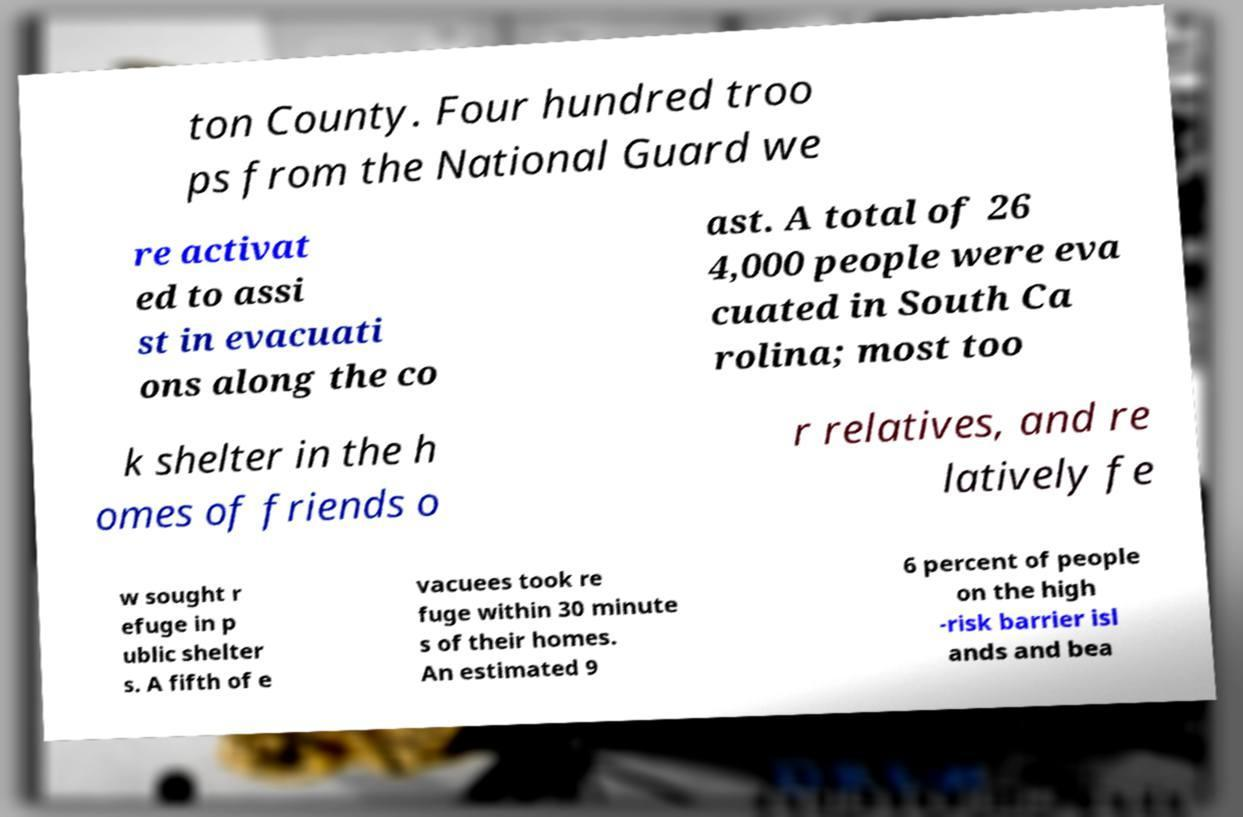Please identify and transcribe the text found in this image. ton County. Four hundred troo ps from the National Guard we re activat ed to assi st in evacuati ons along the co ast. A total of 26 4,000 people were eva cuated in South Ca rolina; most too k shelter in the h omes of friends o r relatives, and re latively fe w sought r efuge in p ublic shelter s. A fifth of e vacuees took re fuge within 30 minute s of their homes. An estimated 9 6 percent of people on the high -risk barrier isl ands and bea 